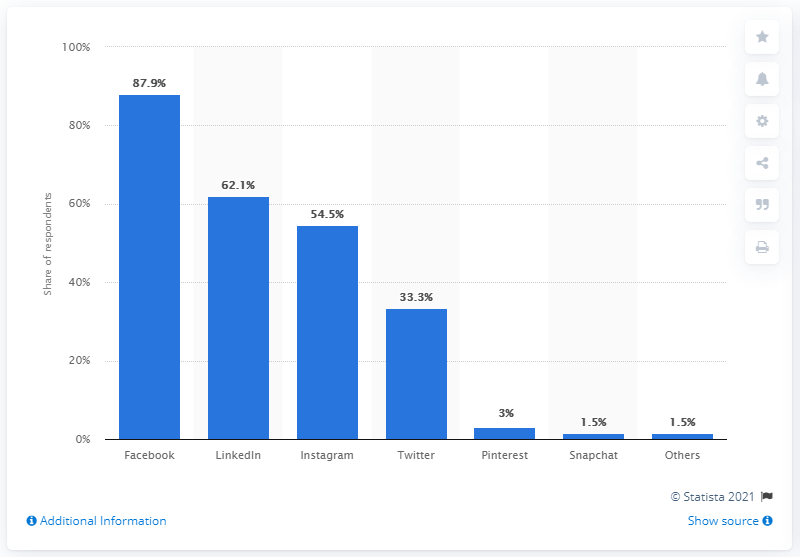Draw attention to some important aspects in this diagram. According to the survey, 54.5% of the respondents used Instagram. 